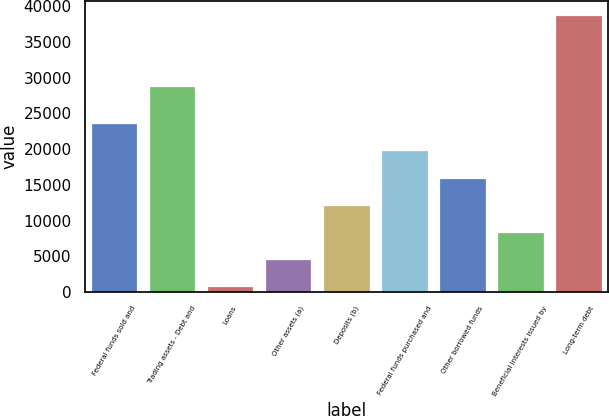<chart> <loc_0><loc_0><loc_500><loc_500><bar_chart><fcel>Federal funds sold and<fcel>Trading assets - Debt and<fcel>Loans<fcel>Other assets (a)<fcel>Deposits (b)<fcel>Federal funds purchased and<fcel>Other borrowed funds<fcel>Beneficial interests issued by<fcel>Long-term debt<nl><fcel>23621.8<fcel>28873<fcel>814<fcel>4615.3<fcel>12217.9<fcel>19820.5<fcel>16019.2<fcel>8416.6<fcel>38827<nl></chart> 